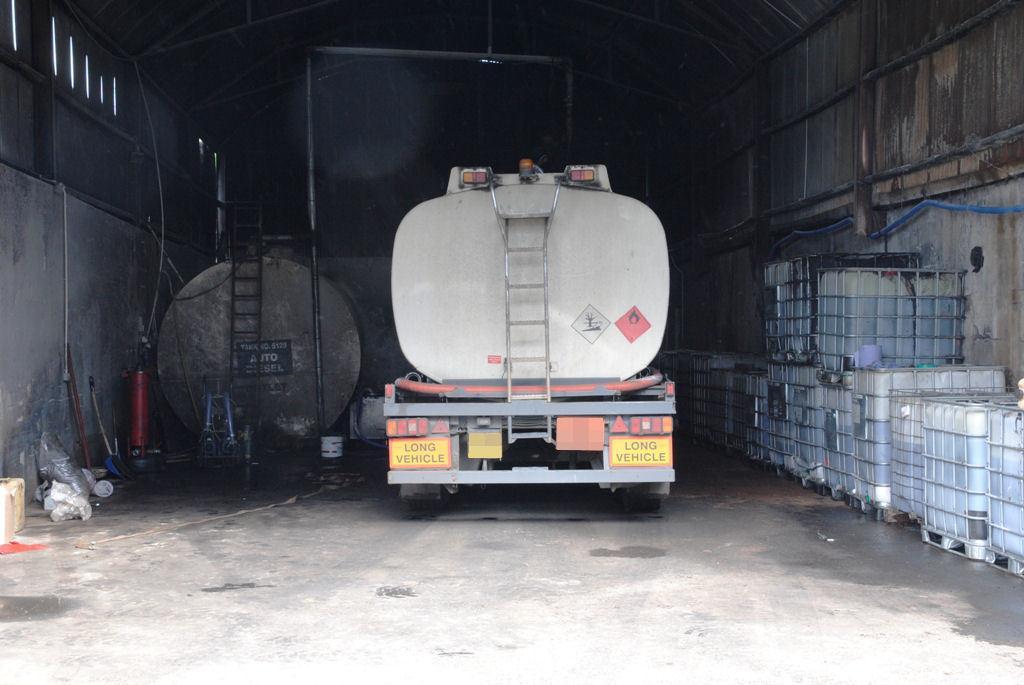In one or two sentences, can you explain what this image depicts? At the center of the image there is a vehicle. On the left and right side of the image there is a wall and few objects placed on the surface. The background is dark. 